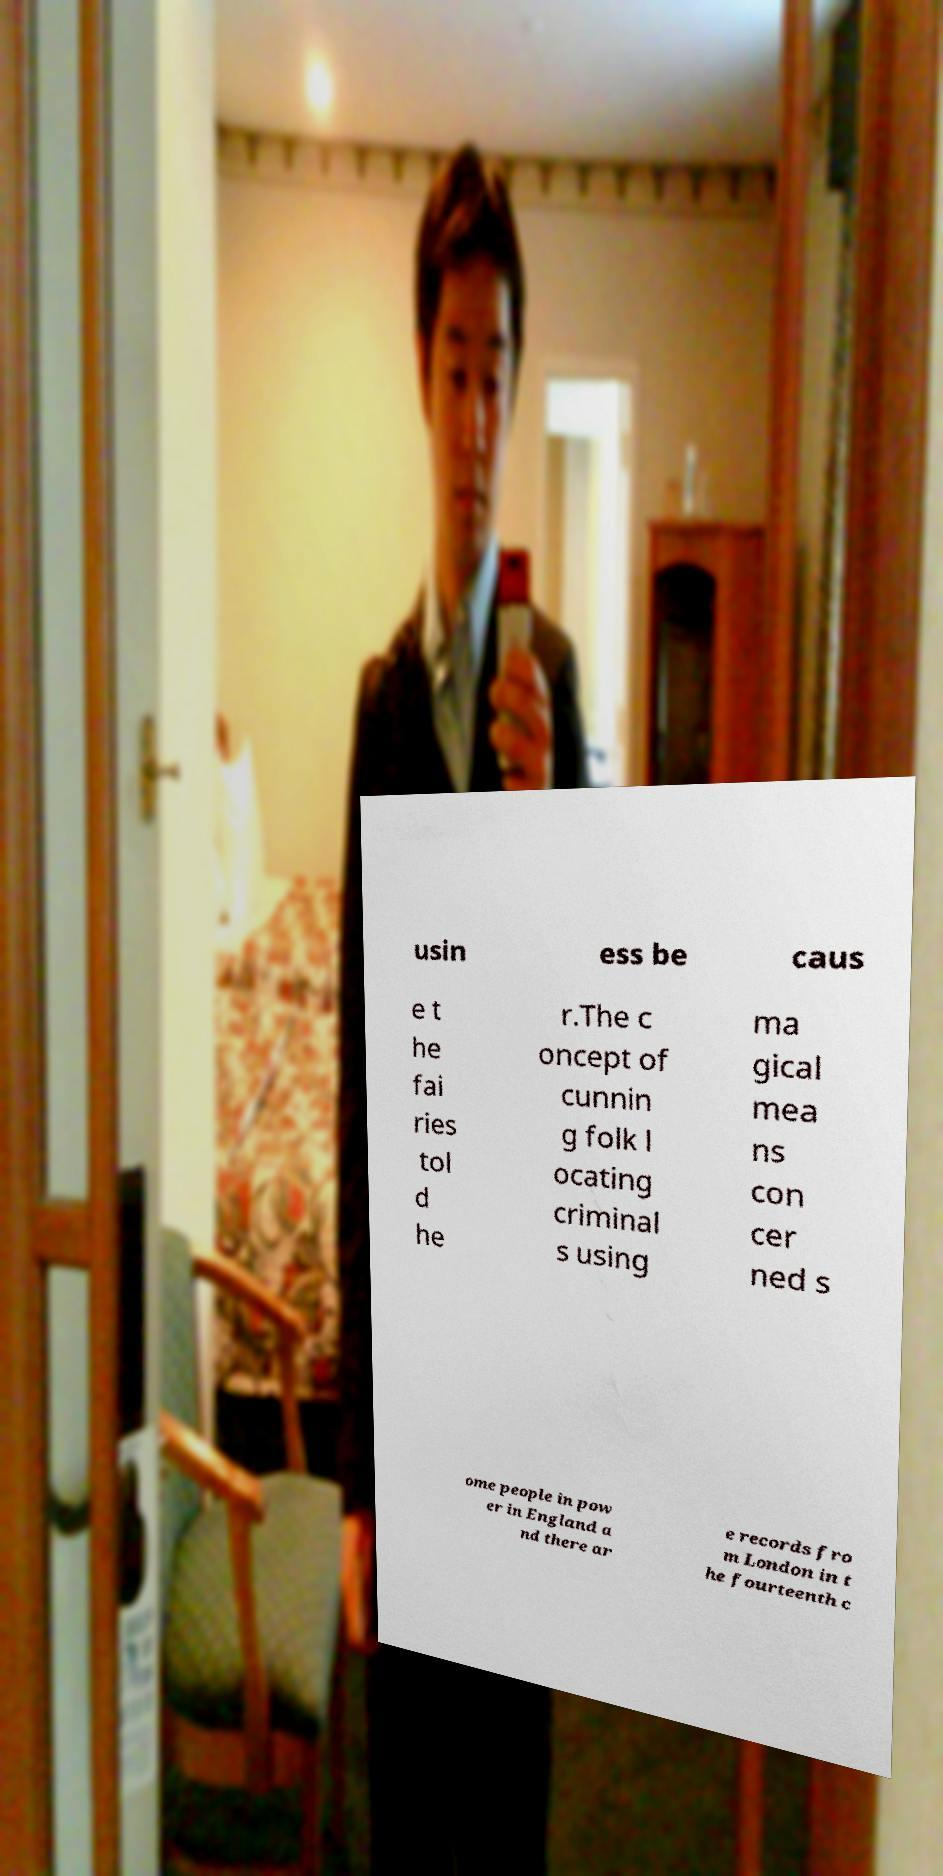I need the written content from this picture converted into text. Can you do that? usin ess be caus e t he fai ries tol d he r.The c oncept of cunnin g folk l ocating criminal s using ma gical mea ns con cer ned s ome people in pow er in England a nd there ar e records fro m London in t he fourteenth c 